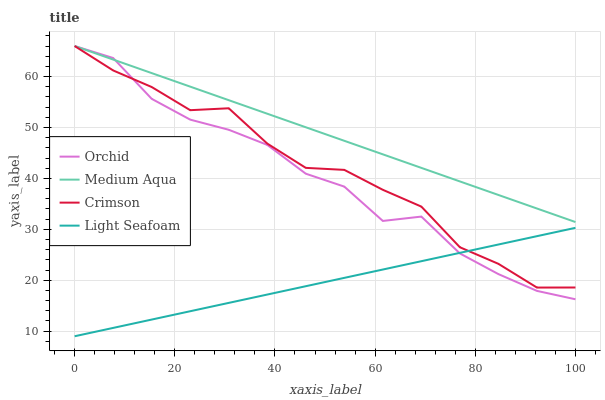Does Medium Aqua have the minimum area under the curve?
Answer yes or no. No. Does Light Seafoam have the maximum area under the curve?
Answer yes or no. No. Is Light Seafoam the smoothest?
Answer yes or no. No. Is Light Seafoam the roughest?
Answer yes or no. No. Does Medium Aqua have the lowest value?
Answer yes or no. No. Does Light Seafoam have the highest value?
Answer yes or no. No. Is Light Seafoam less than Medium Aqua?
Answer yes or no. Yes. Is Medium Aqua greater than Light Seafoam?
Answer yes or no. Yes. Does Light Seafoam intersect Medium Aqua?
Answer yes or no. No. 